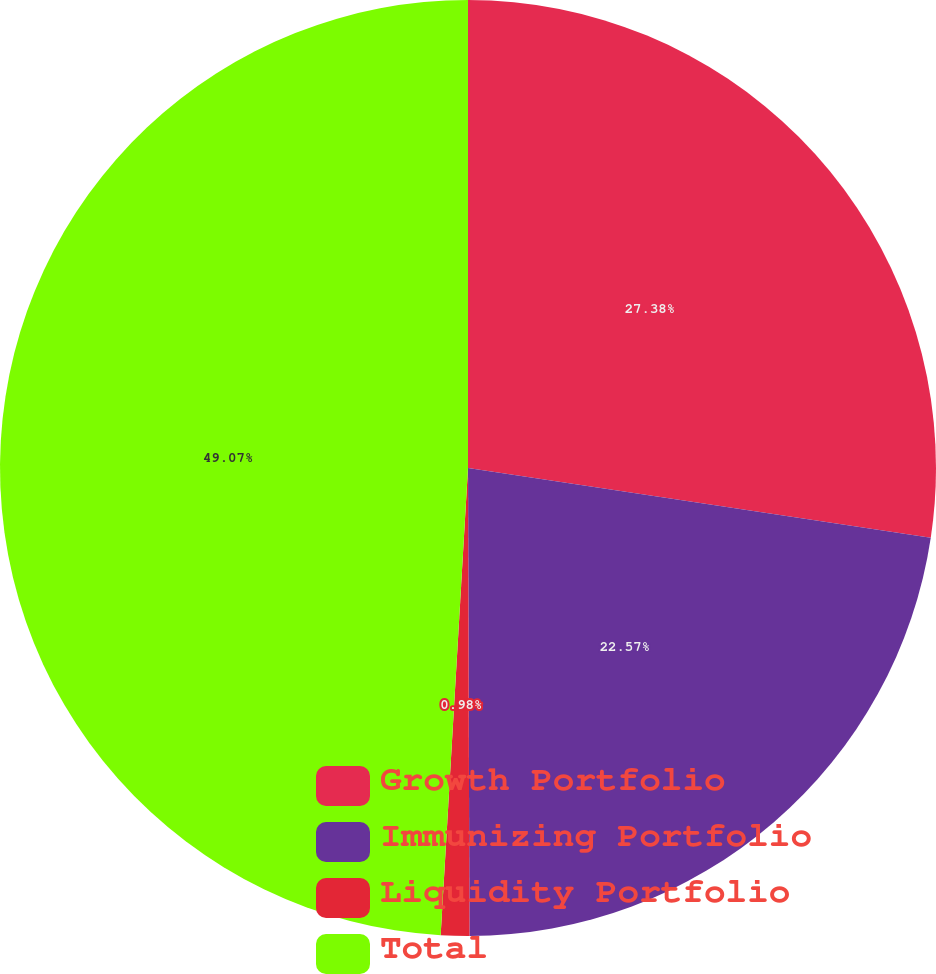<chart> <loc_0><loc_0><loc_500><loc_500><pie_chart><fcel>Growth Portfolio<fcel>Immunizing Portfolio<fcel>Liquidity Portfolio<fcel>Total<nl><fcel>27.38%<fcel>22.57%<fcel>0.98%<fcel>49.07%<nl></chart> 